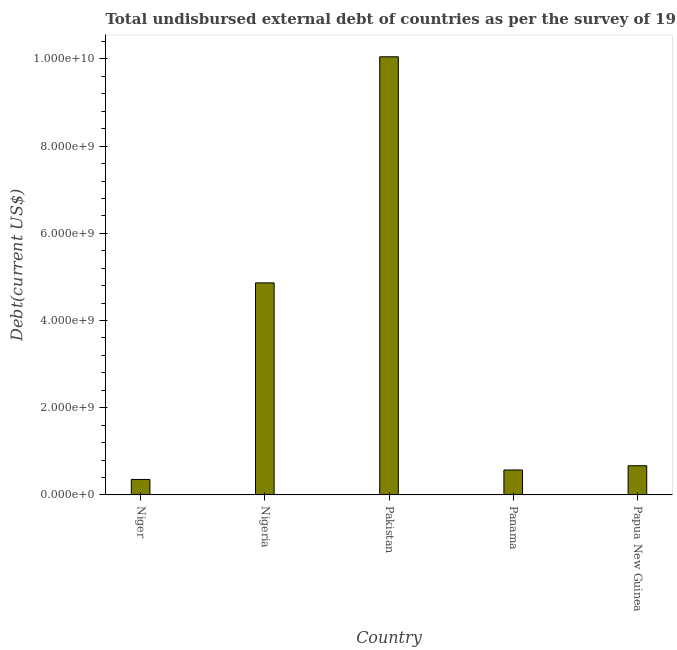Does the graph contain grids?
Your answer should be compact. No. What is the title of the graph?
Your answer should be compact. Total undisbursed external debt of countries as per the survey of 1994. What is the label or title of the Y-axis?
Give a very brief answer. Debt(current US$). What is the total debt in Papua New Guinea?
Give a very brief answer. 6.70e+08. Across all countries, what is the maximum total debt?
Give a very brief answer. 1.01e+1. Across all countries, what is the minimum total debt?
Your answer should be compact. 3.55e+08. In which country was the total debt maximum?
Ensure brevity in your answer.  Pakistan. In which country was the total debt minimum?
Offer a terse response. Niger. What is the sum of the total debt?
Offer a terse response. 1.65e+1. What is the difference between the total debt in Pakistan and Panama?
Give a very brief answer. 9.48e+09. What is the average total debt per country?
Your answer should be compact. 3.30e+09. What is the median total debt?
Provide a short and direct response. 6.70e+08. In how many countries, is the total debt greater than 3200000000 US$?
Make the answer very short. 2. What is the ratio of the total debt in Niger to that in Nigeria?
Give a very brief answer. 0.07. Is the total debt in Panama less than that in Papua New Guinea?
Your answer should be compact. Yes. What is the difference between the highest and the second highest total debt?
Ensure brevity in your answer.  5.19e+09. Is the sum of the total debt in Nigeria and Panama greater than the maximum total debt across all countries?
Offer a very short reply. No. What is the difference between the highest and the lowest total debt?
Your answer should be very brief. 9.70e+09. In how many countries, is the total debt greater than the average total debt taken over all countries?
Offer a terse response. 2. Are all the bars in the graph horizontal?
Your answer should be compact. No. What is the Debt(current US$) of Niger?
Offer a terse response. 3.55e+08. What is the Debt(current US$) of Nigeria?
Your answer should be compact. 4.86e+09. What is the Debt(current US$) in Pakistan?
Ensure brevity in your answer.  1.01e+1. What is the Debt(current US$) of Panama?
Your response must be concise. 5.72e+08. What is the Debt(current US$) in Papua New Guinea?
Your answer should be compact. 6.70e+08. What is the difference between the Debt(current US$) in Niger and Nigeria?
Offer a terse response. -4.51e+09. What is the difference between the Debt(current US$) in Niger and Pakistan?
Provide a succinct answer. -9.70e+09. What is the difference between the Debt(current US$) in Niger and Panama?
Your response must be concise. -2.17e+08. What is the difference between the Debt(current US$) in Niger and Papua New Guinea?
Provide a short and direct response. -3.15e+08. What is the difference between the Debt(current US$) in Nigeria and Pakistan?
Provide a short and direct response. -5.19e+09. What is the difference between the Debt(current US$) in Nigeria and Panama?
Provide a succinct answer. 4.29e+09. What is the difference between the Debt(current US$) in Nigeria and Papua New Guinea?
Make the answer very short. 4.19e+09. What is the difference between the Debt(current US$) in Pakistan and Panama?
Your response must be concise. 9.48e+09. What is the difference between the Debt(current US$) in Pakistan and Papua New Guinea?
Provide a short and direct response. 9.38e+09. What is the difference between the Debt(current US$) in Panama and Papua New Guinea?
Your answer should be compact. -9.75e+07. What is the ratio of the Debt(current US$) in Niger to that in Nigeria?
Your answer should be very brief. 0.07. What is the ratio of the Debt(current US$) in Niger to that in Pakistan?
Make the answer very short. 0.04. What is the ratio of the Debt(current US$) in Niger to that in Panama?
Your answer should be compact. 0.62. What is the ratio of the Debt(current US$) in Niger to that in Papua New Guinea?
Offer a very short reply. 0.53. What is the ratio of the Debt(current US$) in Nigeria to that in Pakistan?
Ensure brevity in your answer.  0.48. What is the ratio of the Debt(current US$) in Nigeria to that in Panama?
Make the answer very short. 8.5. What is the ratio of the Debt(current US$) in Nigeria to that in Papua New Guinea?
Offer a terse response. 7.26. What is the ratio of the Debt(current US$) in Pakistan to that in Panama?
Your answer should be compact. 17.56. What is the ratio of the Debt(current US$) in Pakistan to that in Papua New Guinea?
Ensure brevity in your answer.  15.01. What is the ratio of the Debt(current US$) in Panama to that in Papua New Guinea?
Ensure brevity in your answer.  0.85. 